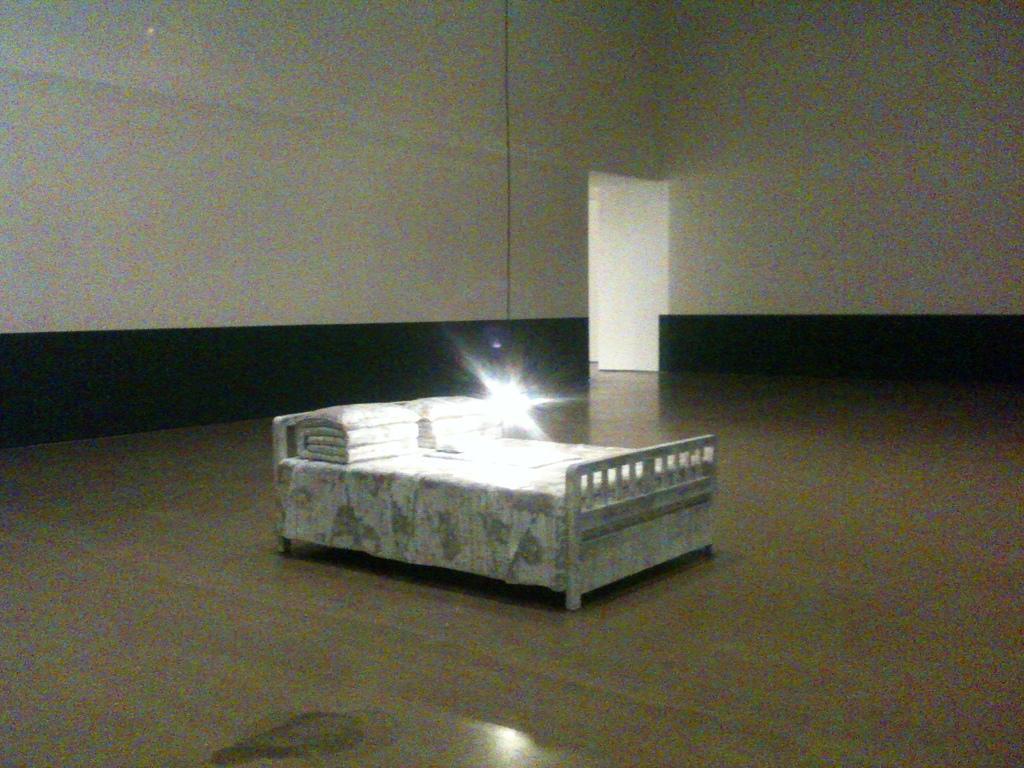Could you give a brief overview of what you see in this image? There is a white color bed on the floor. There are pillows arranged on the bed near a light arranged. In the background, there is white color door near white wall. 